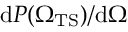<formula> <loc_0><loc_0><loc_500><loc_500>d P ( { \Omega _ { T S } } ) / d \Omega</formula> 